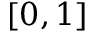Convert formula to latex. <formula><loc_0><loc_0><loc_500><loc_500>[ 0 , 1 ]</formula> 